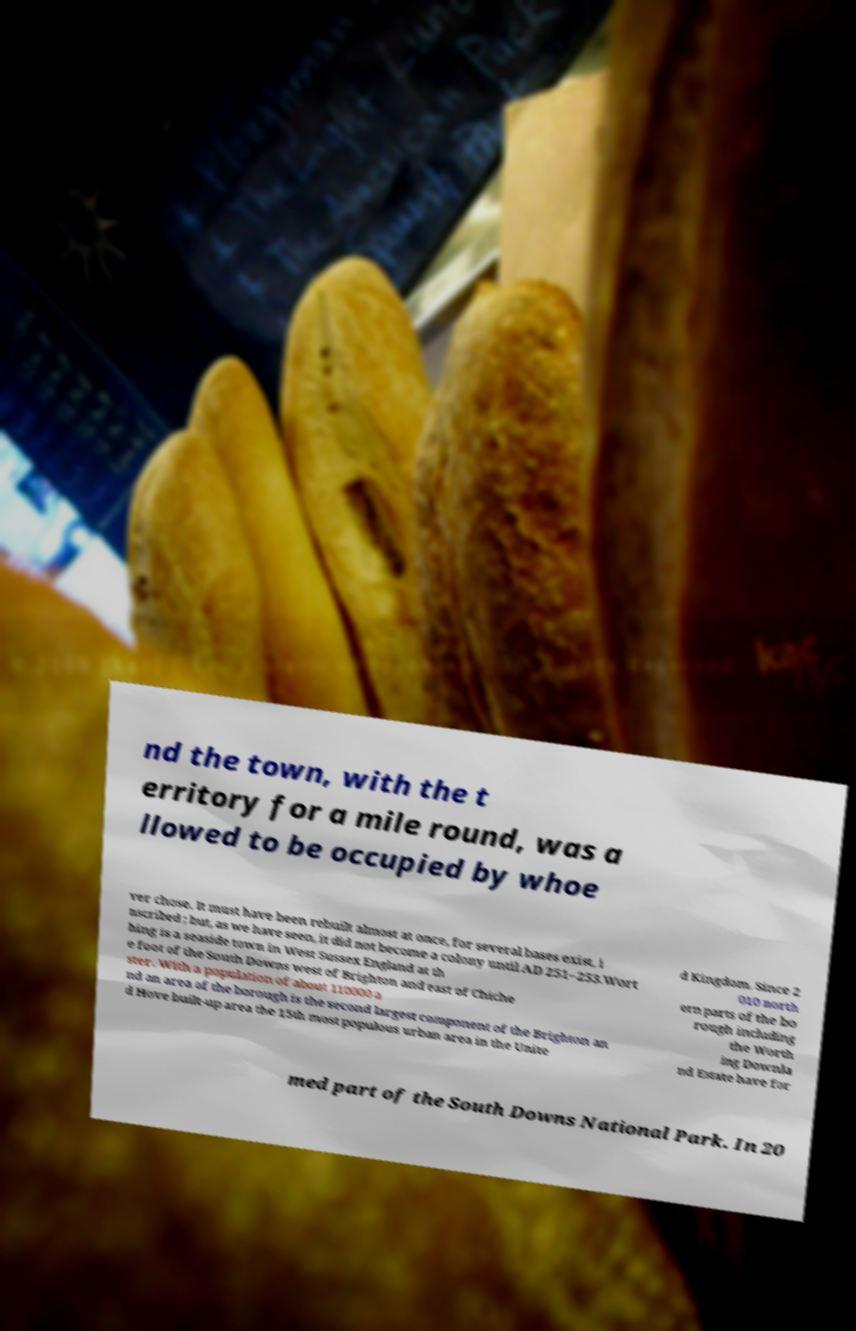For documentation purposes, I need the text within this image transcribed. Could you provide that? nd the town, with the t erritory for a mile round, was a llowed to be occupied by whoe ver chose. It must have been rebuilt almost at once, for several bases exist, i nscribed ; but, as we have seen, it did not become a colony until AD 251–253.Wort hing is a seaside town in West Sussex England at th e foot of the South Downs west of Brighton and east of Chiche ster. With a population of about 110000 a nd an area of the borough is the second largest component of the Brighton an d Hove built-up area the 15th most populous urban area in the Unite d Kingdom. Since 2 010 north ern parts of the bo rough including the Worth ing Downla nd Estate have for med part of the South Downs National Park. In 20 